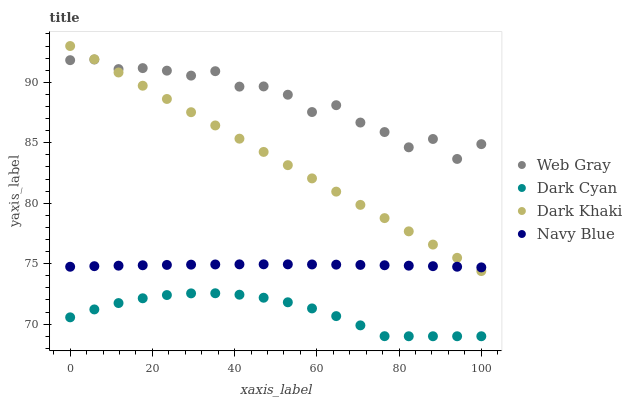Does Dark Cyan have the minimum area under the curve?
Answer yes or no. Yes. Does Web Gray have the maximum area under the curve?
Answer yes or no. Yes. Does Dark Khaki have the minimum area under the curve?
Answer yes or no. No. Does Dark Khaki have the maximum area under the curve?
Answer yes or no. No. Is Dark Khaki the smoothest?
Answer yes or no. Yes. Is Web Gray the roughest?
Answer yes or no. Yes. Is Web Gray the smoothest?
Answer yes or no. No. Is Dark Khaki the roughest?
Answer yes or no. No. Does Dark Cyan have the lowest value?
Answer yes or no. Yes. Does Dark Khaki have the lowest value?
Answer yes or no. No. Does Dark Khaki have the highest value?
Answer yes or no. Yes. Does Web Gray have the highest value?
Answer yes or no. No. Is Dark Cyan less than Dark Khaki?
Answer yes or no. Yes. Is Web Gray greater than Dark Cyan?
Answer yes or no. Yes. Does Navy Blue intersect Dark Khaki?
Answer yes or no. Yes. Is Navy Blue less than Dark Khaki?
Answer yes or no. No. Is Navy Blue greater than Dark Khaki?
Answer yes or no. No. Does Dark Cyan intersect Dark Khaki?
Answer yes or no. No. 